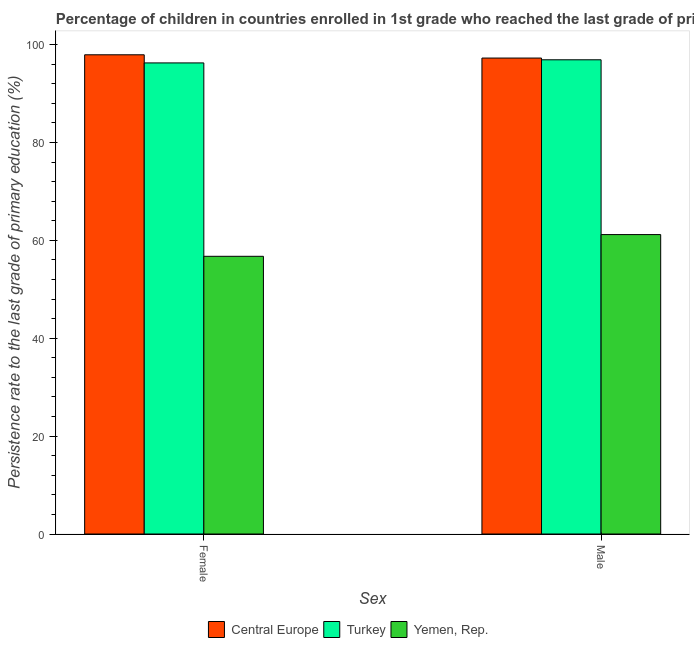How many different coloured bars are there?
Your answer should be very brief. 3. How many groups of bars are there?
Make the answer very short. 2. Are the number of bars per tick equal to the number of legend labels?
Offer a very short reply. Yes. Are the number of bars on each tick of the X-axis equal?
Provide a succinct answer. Yes. How many bars are there on the 2nd tick from the right?
Offer a terse response. 3. What is the persistence rate of female students in Turkey?
Provide a succinct answer. 96.27. Across all countries, what is the maximum persistence rate of female students?
Your response must be concise. 97.94. Across all countries, what is the minimum persistence rate of female students?
Give a very brief answer. 56.75. In which country was the persistence rate of male students maximum?
Provide a succinct answer. Central Europe. In which country was the persistence rate of female students minimum?
Provide a short and direct response. Yemen, Rep. What is the total persistence rate of female students in the graph?
Ensure brevity in your answer.  250.96. What is the difference between the persistence rate of male students in Central Europe and that in Turkey?
Provide a short and direct response. 0.35. What is the difference between the persistence rate of female students in Turkey and the persistence rate of male students in Central Europe?
Ensure brevity in your answer.  -0.99. What is the average persistence rate of female students per country?
Offer a very short reply. 83.65. What is the difference between the persistence rate of male students and persistence rate of female students in Central Europe?
Your response must be concise. -0.67. What is the ratio of the persistence rate of male students in Central Europe to that in Yemen, Rep.?
Your answer should be very brief. 1.59. What does the 2nd bar from the left in Male represents?
Your response must be concise. Turkey. How many countries are there in the graph?
Your answer should be very brief. 3. What is the difference between two consecutive major ticks on the Y-axis?
Offer a terse response. 20. Are the values on the major ticks of Y-axis written in scientific E-notation?
Your answer should be compact. No. Where does the legend appear in the graph?
Your answer should be compact. Bottom center. How many legend labels are there?
Your response must be concise. 3. What is the title of the graph?
Keep it short and to the point. Percentage of children in countries enrolled in 1st grade who reached the last grade of primary education. What is the label or title of the X-axis?
Ensure brevity in your answer.  Sex. What is the label or title of the Y-axis?
Offer a very short reply. Persistence rate to the last grade of primary education (%). What is the Persistence rate to the last grade of primary education (%) of Central Europe in Female?
Offer a very short reply. 97.94. What is the Persistence rate to the last grade of primary education (%) of Turkey in Female?
Make the answer very short. 96.27. What is the Persistence rate to the last grade of primary education (%) of Yemen, Rep. in Female?
Ensure brevity in your answer.  56.75. What is the Persistence rate to the last grade of primary education (%) of Central Europe in Male?
Keep it short and to the point. 97.27. What is the Persistence rate to the last grade of primary education (%) of Turkey in Male?
Offer a terse response. 96.91. What is the Persistence rate to the last grade of primary education (%) of Yemen, Rep. in Male?
Offer a terse response. 61.19. Across all Sex, what is the maximum Persistence rate to the last grade of primary education (%) in Central Europe?
Ensure brevity in your answer.  97.94. Across all Sex, what is the maximum Persistence rate to the last grade of primary education (%) in Turkey?
Ensure brevity in your answer.  96.91. Across all Sex, what is the maximum Persistence rate to the last grade of primary education (%) in Yemen, Rep.?
Your answer should be compact. 61.19. Across all Sex, what is the minimum Persistence rate to the last grade of primary education (%) of Central Europe?
Your response must be concise. 97.27. Across all Sex, what is the minimum Persistence rate to the last grade of primary education (%) in Turkey?
Your answer should be compact. 96.27. Across all Sex, what is the minimum Persistence rate to the last grade of primary education (%) of Yemen, Rep.?
Provide a short and direct response. 56.75. What is the total Persistence rate to the last grade of primary education (%) in Central Europe in the graph?
Offer a very short reply. 195.2. What is the total Persistence rate to the last grade of primary education (%) in Turkey in the graph?
Give a very brief answer. 193.19. What is the total Persistence rate to the last grade of primary education (%) of Yemen, Rep. in the graph?
Your answer should be very brief. 117.94. What is the difference between the Persistence rate to the last grade of primary education (%) in Central Europe in Female and that in Male?
Your response must be concise. 0.67. What is the difference between the Persistence rate to the last grade of primary education (%) of Turkey in Female and that in Male?
Your answer should be compact. -0.64. What is the difference between the Persistence rate to the last grade of primary education (%) in Yemen, Rep. in Female and that in Male?
Provide a short and direct response. -4.44. What is the difference between the Persistence rate to the last grade of primary education (%) in Central Europe in Female and the Persistence rate to the last grade of primary education (%) in Turkey in Male?
Your answer should be compact. 1.02. What is the difference between the Persistence rate to the last grade of primary education (%) in Central Europe in Female and the Persistence rate to the last grade of primary education (%) in Yemen, Rep. in Male?
Your answer should be compact. 36.75. What is the difference between the Persistence rate to the last grade of primary education (%) of Turkey in Female and the Persistence rate to the last grade of primary education (%) of Yemen, Rep. in Male?
Your answer should be compact. 35.08. What is the average Persistence rate to the last grade of primary education (%) of Central Europe per Sex?
Your answer should be very brief. 97.6. What is the average Persistence rate to the last grade of primary education (%) in Turkey per Sex?
Provide a short and direct response. 96.59. What is the average Persistence rate to the last grade of primary education (%) in Yemen, Rep. per Sex?
Offer a terse response. 58.97. What is the difference between the Persistence rate to the last grade of primary education (%) in Central Europe and Persistence rate to the last grade of primary education (%) in Turkey in Female?
Keep it short and to the point. 1.66. What is the difference between the Persistence rate to the last grade of primary education (%) in Central Europe and Persistence rate to the last grade of primary education (%) in Yemen, Rep. in Female?
Provide a short and direct response. 41.18. What is the difference between the Persistence rate to the last grade of primary education (%) of Turkey and Persistence rate to the last grade of primary education (%) of Yemen, Rep. in Female?
Give a very brief answer. 39.52. What is the difference between the Persistence rate to the last grade of primary education (%) of Central Europe and Persistence rate to the last grade of primary education (%) of Turkey in Male?
Provide a succinct answer. 0.35. What is the difference between the Persistence rate to the last grade of primary education (%) in Central Europe and Persistence rate to the last grade of primary education (%) in Yemen, Rep. in Male?
Make the answer very short. 36.08. What is the difference between the Persistence rate to the last grade of primary education (%) of Turkey and Persistence rate to the last grade of primary education (%) of Yemen, Rep. in Male?
Make the answer very short. 35.72. What is the ratio of the Persistence rate to the last grade of primary education (%) in Central Europe in Female to that in Male?
Keep it short and to the point. 1.01. What is the ratio of the Persistence rate to the last grade of primary education (%) of Turkey in Female to that in Male?
Ensure brevity in your answer.  0.99. What is the ratio of the Persistence rate to the last grade of primary education (%) in Yemen, Rep. in Female to that in Male?
Ensure brevity in your answer.  0.93. What is the difference between the highest and the second highest Persistence rate to the last grade of primary education (%) of Central Europe?
Your answer should be compact. 0.67. What is the difference between the highest and the second highest Persistence rate to the last grade of primary education (%) of Turkey?
Provide a succinct answer. 0.64. What is the difference between the highest and the second highest Persistence rate to the last grade of primary education (%) in Yemen, Rep.?
Make the answer very short. 4.44. What is the difference between the highest and the lowest Persistence rate to the last grade of primary education (%) of Central Europe?
Offer a terse response. 0.67. What is the difference between the highest and the lowest Persistence rate to the last grade of primary education (%) of Turkey?
Provide a succinct answer. 0.64. What is the difference between the highest and the lowest Persistence rate to the last grade of primary education (%) of Yemen, Rep.?
Give a very brief answer. 4.44. 